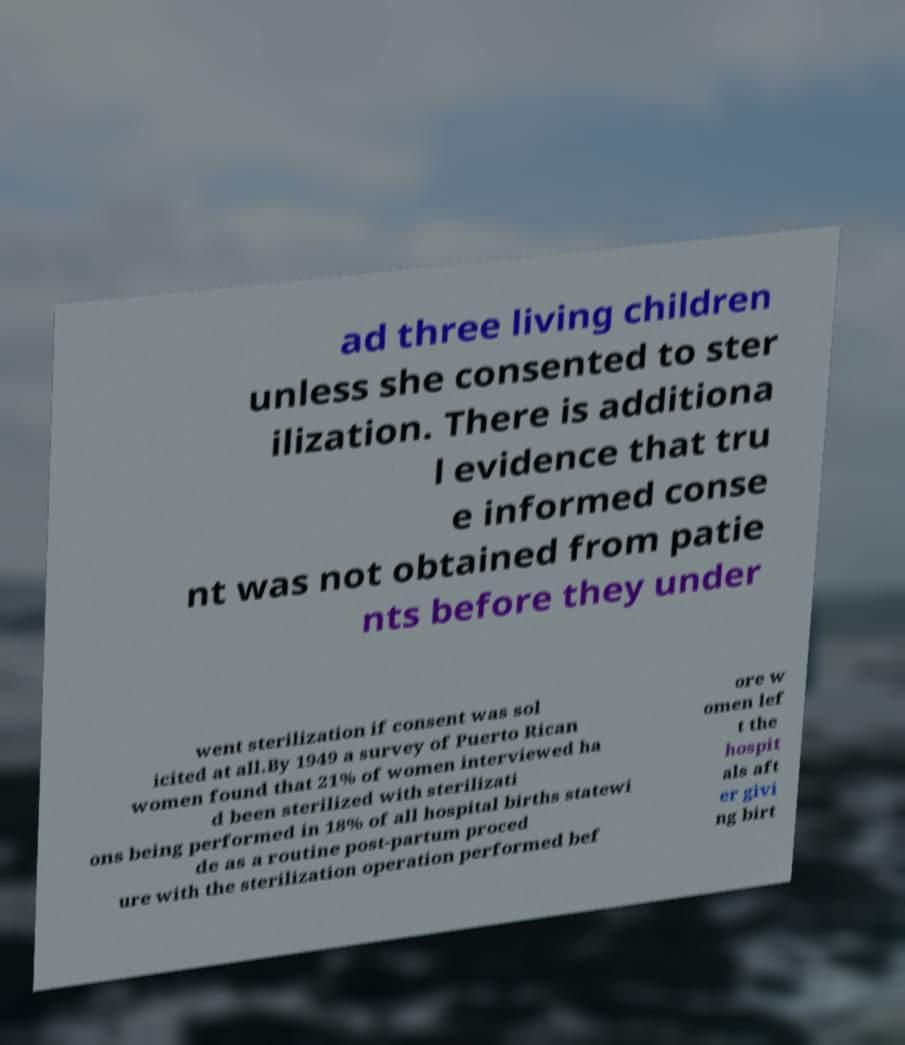I need the written content from this picture converted into text. Can you do that? ad three living children unless she consented to ster ilization. There is additiona l evidence that tru e informed conse nt was not obtained from patie nts before they under went sterilization if consent was sol icited at all.By 1949 a survey of Puerto Rican women found that 21% of women interviewed ha d been sterilized with sterilizati ons being performed in 18% of all hospital births statewi de as a routine post-partum proced ure with the sterilization operation performed bef ore w omen lef t the hospit als aft er givi ng birt 